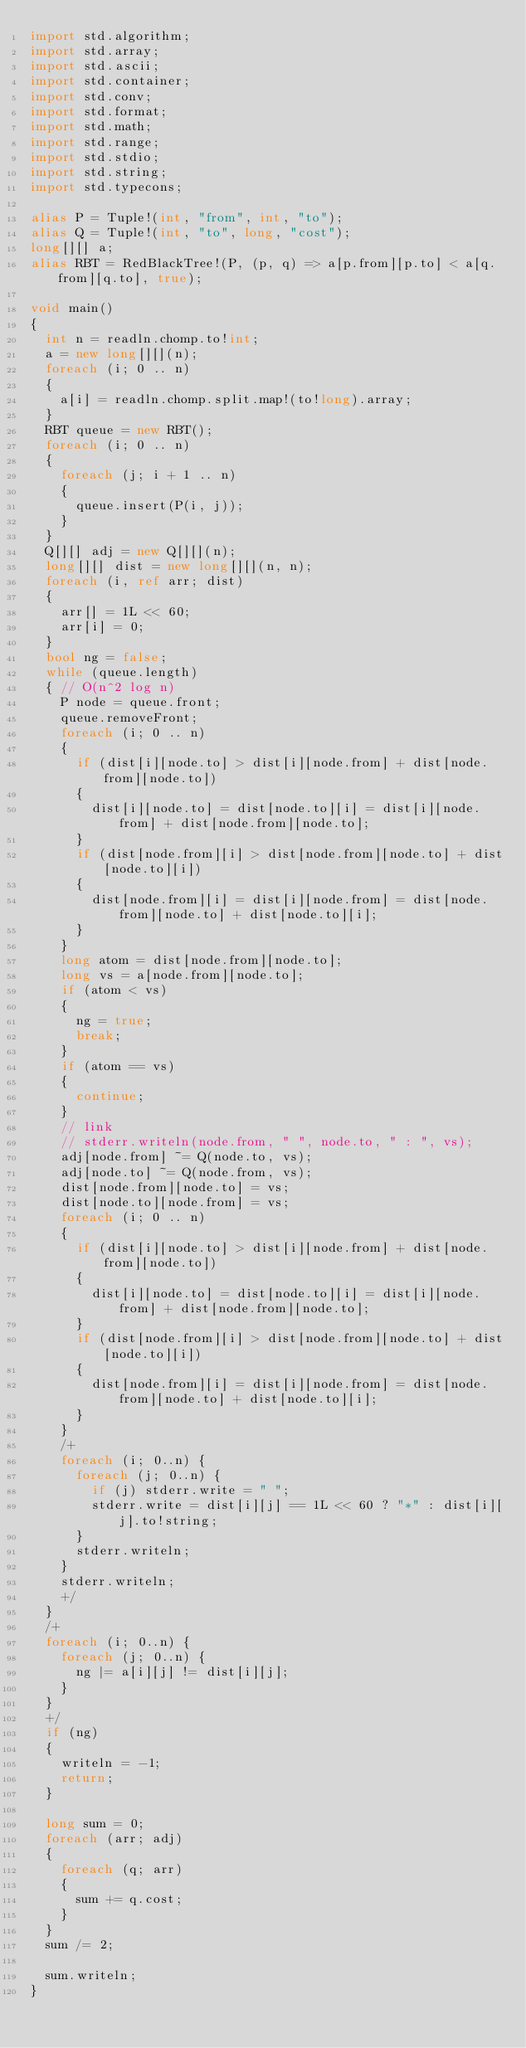<code> <loc_0><loc_0><loc_500><loc_500><_D_>import std.algorithm;
import std.array;
import std.ascii;
import std.container;
import std.conv;
import std.format;
import std.math;
import std.range;
import std.stdio;
import std.string;
import std.typecons;

alias P = Tuple!(int, "from", int, "to");
alias Q = Tuple!(int, "to", long, "cost");
long[][] a;
alias RBT = RedBlackTree!(P, (p, q) => a[p.from][p.to] < a[q.from][q.to], true);

void main()
{
  int n = readln.chomp.to!int;
  a = new long[][](n);
  foreach (i; 0 .. n)
  {
    a[i] = readln.chomp.split.map!(to!long).array;
  }
  RBT queue = new RBT();
  foreach (i; 0 .. n)
  {
    foreach (j; i + 1 .. n)
    {
      queue.insert(P(i, j));
    }
  }
  Q[][] adj = new Q[][](n);
  long[][] dist = new long[][](n, n);
  foreach (i, ref arr; dist)
  {
    arr[] = 1L << 60;
    arr[i] = 0;
  }
  bool ng = false;
  while (queue.length)
  { // O(n^2 log n)
    P node = queue.front;
    queue.removeFront;
    foreach (i; 0 .. n)
    {
      if (dist[i][node.to] > dist[i][node.from] + dist[node.from][node.to])
      {
        dist[i][node.to] = dist[node.to][i] = dist[i][node.from] + dist[node.from][node.to];
      }
      if (dist[node.from][i] > dist[node.from][node.to] + dist[node.to][i])
      {
        dist[node.from][i] = dist[i][node.from] = dist[node.from][node.to] + dist[node.to][i];
      }
    }
    long atom = dist[node.from][node.to];
    long vs = a[node.from][node.to];
    if (atom < vs)
    {
      ng = true;
      break;
    }
    if (atom == vs)
    {
      continue;
    }
    // link
    // stderr.writeln(node.from, " ", node.to, " : ", vs);
    adj[node.from] ~= Q(node.to, vs);
    adj[node.to] ~= Q(node.from, vs);
    dist[node.from][node.to] = vs;
    dist[node.to][node.from] = vs;
    foreach (i; 0 .. n)
    {
      if (dist[i][node.to] > dist[i][node.from] + dist[node.from][node.to])
      {
        dist[i][node.to] = dist[node.to][i] = dist[i][node.from] + dist[node.from][node.to];
      }
      if (dist[node.from][i] > dist[node.from][node.to] + dist[node.to][i])
      {
        dist[node.from][i] = dist[i][node.from] = dist[node.from][node.to] + dist[node.to][i];
      }
    }
    /+
    foreach (i; 0..n) {
      foreach (j; 0..n) {
        if (j) stderr.write = " ";
        stderr.write = dist[i][j] == 1L << 60 ? "*" : dist[i][j].to!string;
      }
      stderr.writeln;
    }
    stderr.writeln;
    +/
  }
  /+
  foreach (i; 0..n) {
    foreach (j; 0..n) {
      ng |= a[i][j] != dist[i][j];
    }
  }
  +/
  if (ng)
  {
    writeln = -1;
    return;
  }

  long sum = 0;
  foreach (arr; adj)
  {
    foreach (q; arr)
    {
      sum += q.cost;
    }
  }
  sum /= 2;
  
  sum.writeln;
}
</code> 